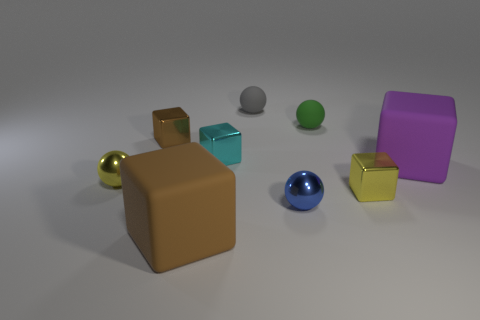Subtract all brown blocks. How many blocks are left? 3 Subtract all brown blocks. How many blocks are left? 3 Subtract all balls. How many objects are left? 5 Subtract 2 cubes. How many cubes are left? 3 Add 9 small red rubber cubes. How many small red rubber cubes exist? 9 Subtract 0 brown cylinders. How many objects are left? 9 Subtract all blue cubes. Subtract all red spheres. How many cubes are left? 5 Subtract all green cubes. How many yellow spheres are left? 1 Subtract all large purple objects. Subtract all big brown blocks. How many objects are left? 7 Add 1 blue shiny things. How many blue shiny things are left? 2 